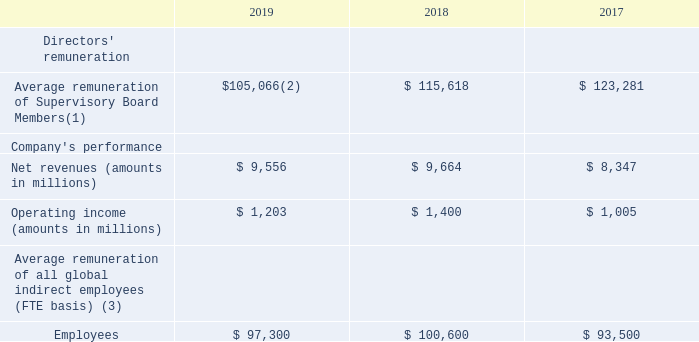(1) Using the euro per US dollar exchange rate on December 31, 2019 of €1 = $1.1213.
(2) Since May 23, 2019 Mr. Manzi has not been a member of the Supervisory Board.
(3) Global indirect employees are all employees other than those directly manufacturing our products.
We do not have any service agreements with members of our Supervisory Board. We did not extend any loans or overdrafts to any of our Supervisory Board members. Furthermore, we have not guaranteed any debts or concluded any leases with any of our Supervisory Board members or their families.
What was the exchange rate used for EUR to USD on 31 December 2019? €1 = $1.1213. Since when has Mr. Manzi not been a part of the supervisory board? May 23, 2019. What is the comment on the status of Global indirect employees? Global indirect employees are all employees other than those directly manufacturing our products. What was the increase / (decrease) in the Average remuneration of Supervisory Board Members from 2018 to 2019?
Answer scale should be: million. 105,066 - 115,618
Answer: -10552. What was the average Net Revenues?
Answer scale should be: million. (9,556 + 9,664 + 8,347) / 3
Answer: 9189. What is the percentage increase / (decrease) in Operating income from 2018 to 2019?
Answer scale should be: percent. 1,203 / 1,400 - 1
Answer: -14.07. 